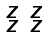Convert formula to latex. <formula><loc_0><loc_0><loc_500><loc_500>\begin{smallmatrix} z & z \\ z & z \end{smallmatrix}</formula> 